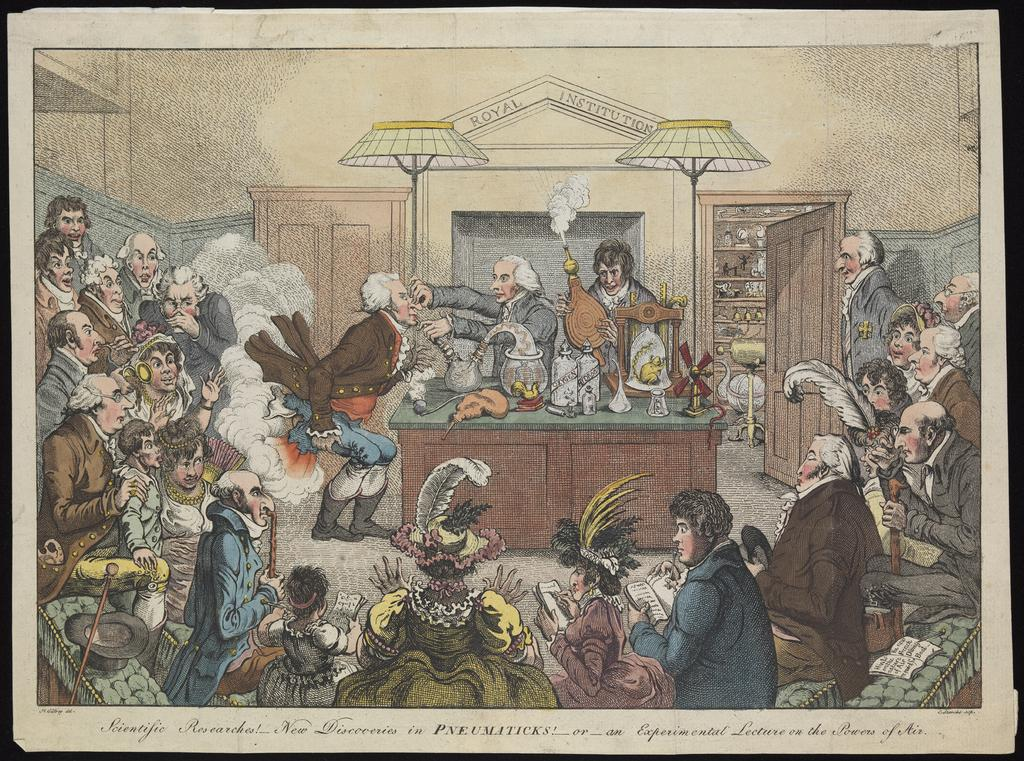<image>
Create a compact narrative representing the image presented. An old paintingof a scienee lab is titled Scientific Researches 